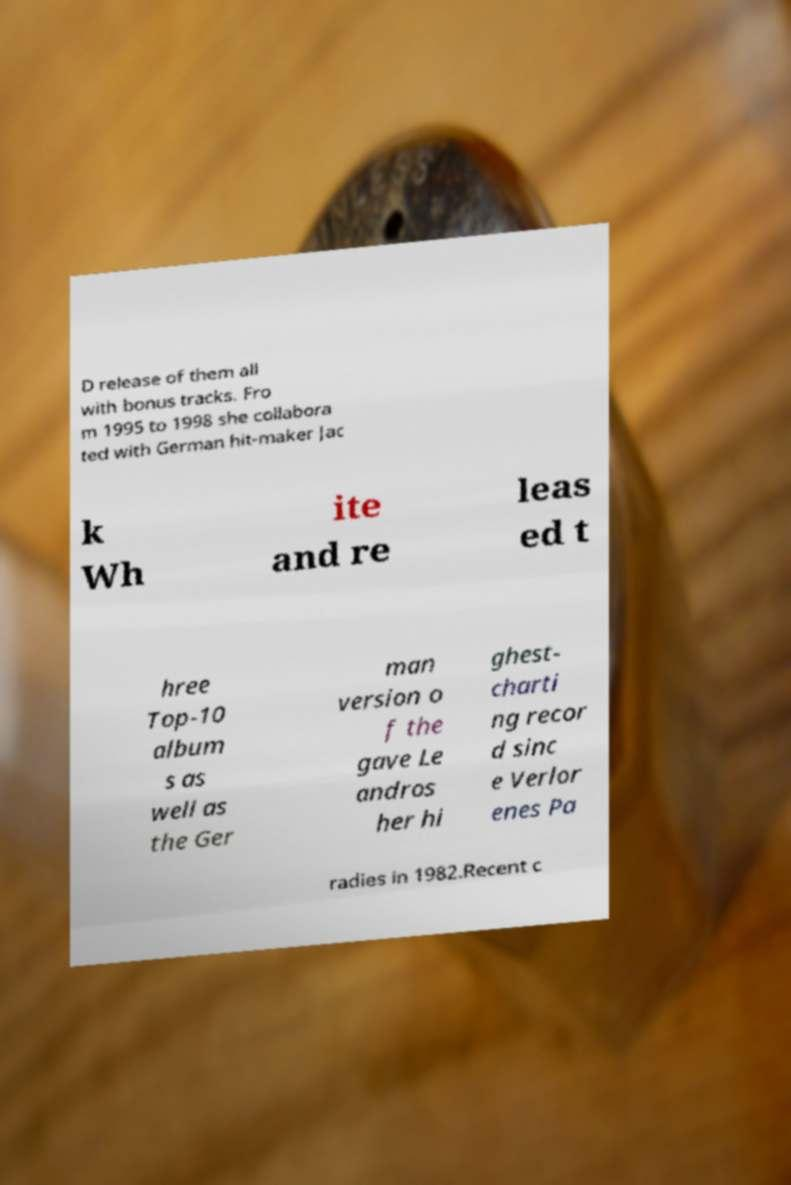Please read and relay the text visible in this image. What does it say? D release of them all with bonus tracks. Fro m 1995 to 1998 she collabora ted with German hit-maker Jac k Wh ite and re leas ed t hree Top-10 album s as well as the Ger man version o f the gave Le andros her hi ghest- charti ng recor d sinc e Verlor enes Pa radies in 1982.Recent c 